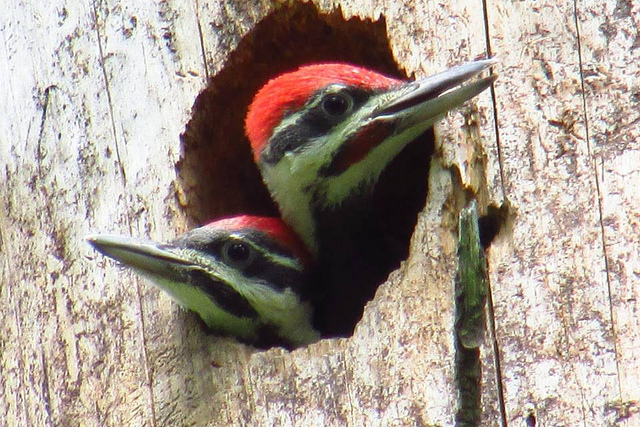Can you describe their natural habitat? Pileated woodpeckers are typically found in large, mature forests with a high availability of dead trees used for nesting and feeding. They prefer heavily wooded areas, often with a mix of deciduous and coniferous trees. 